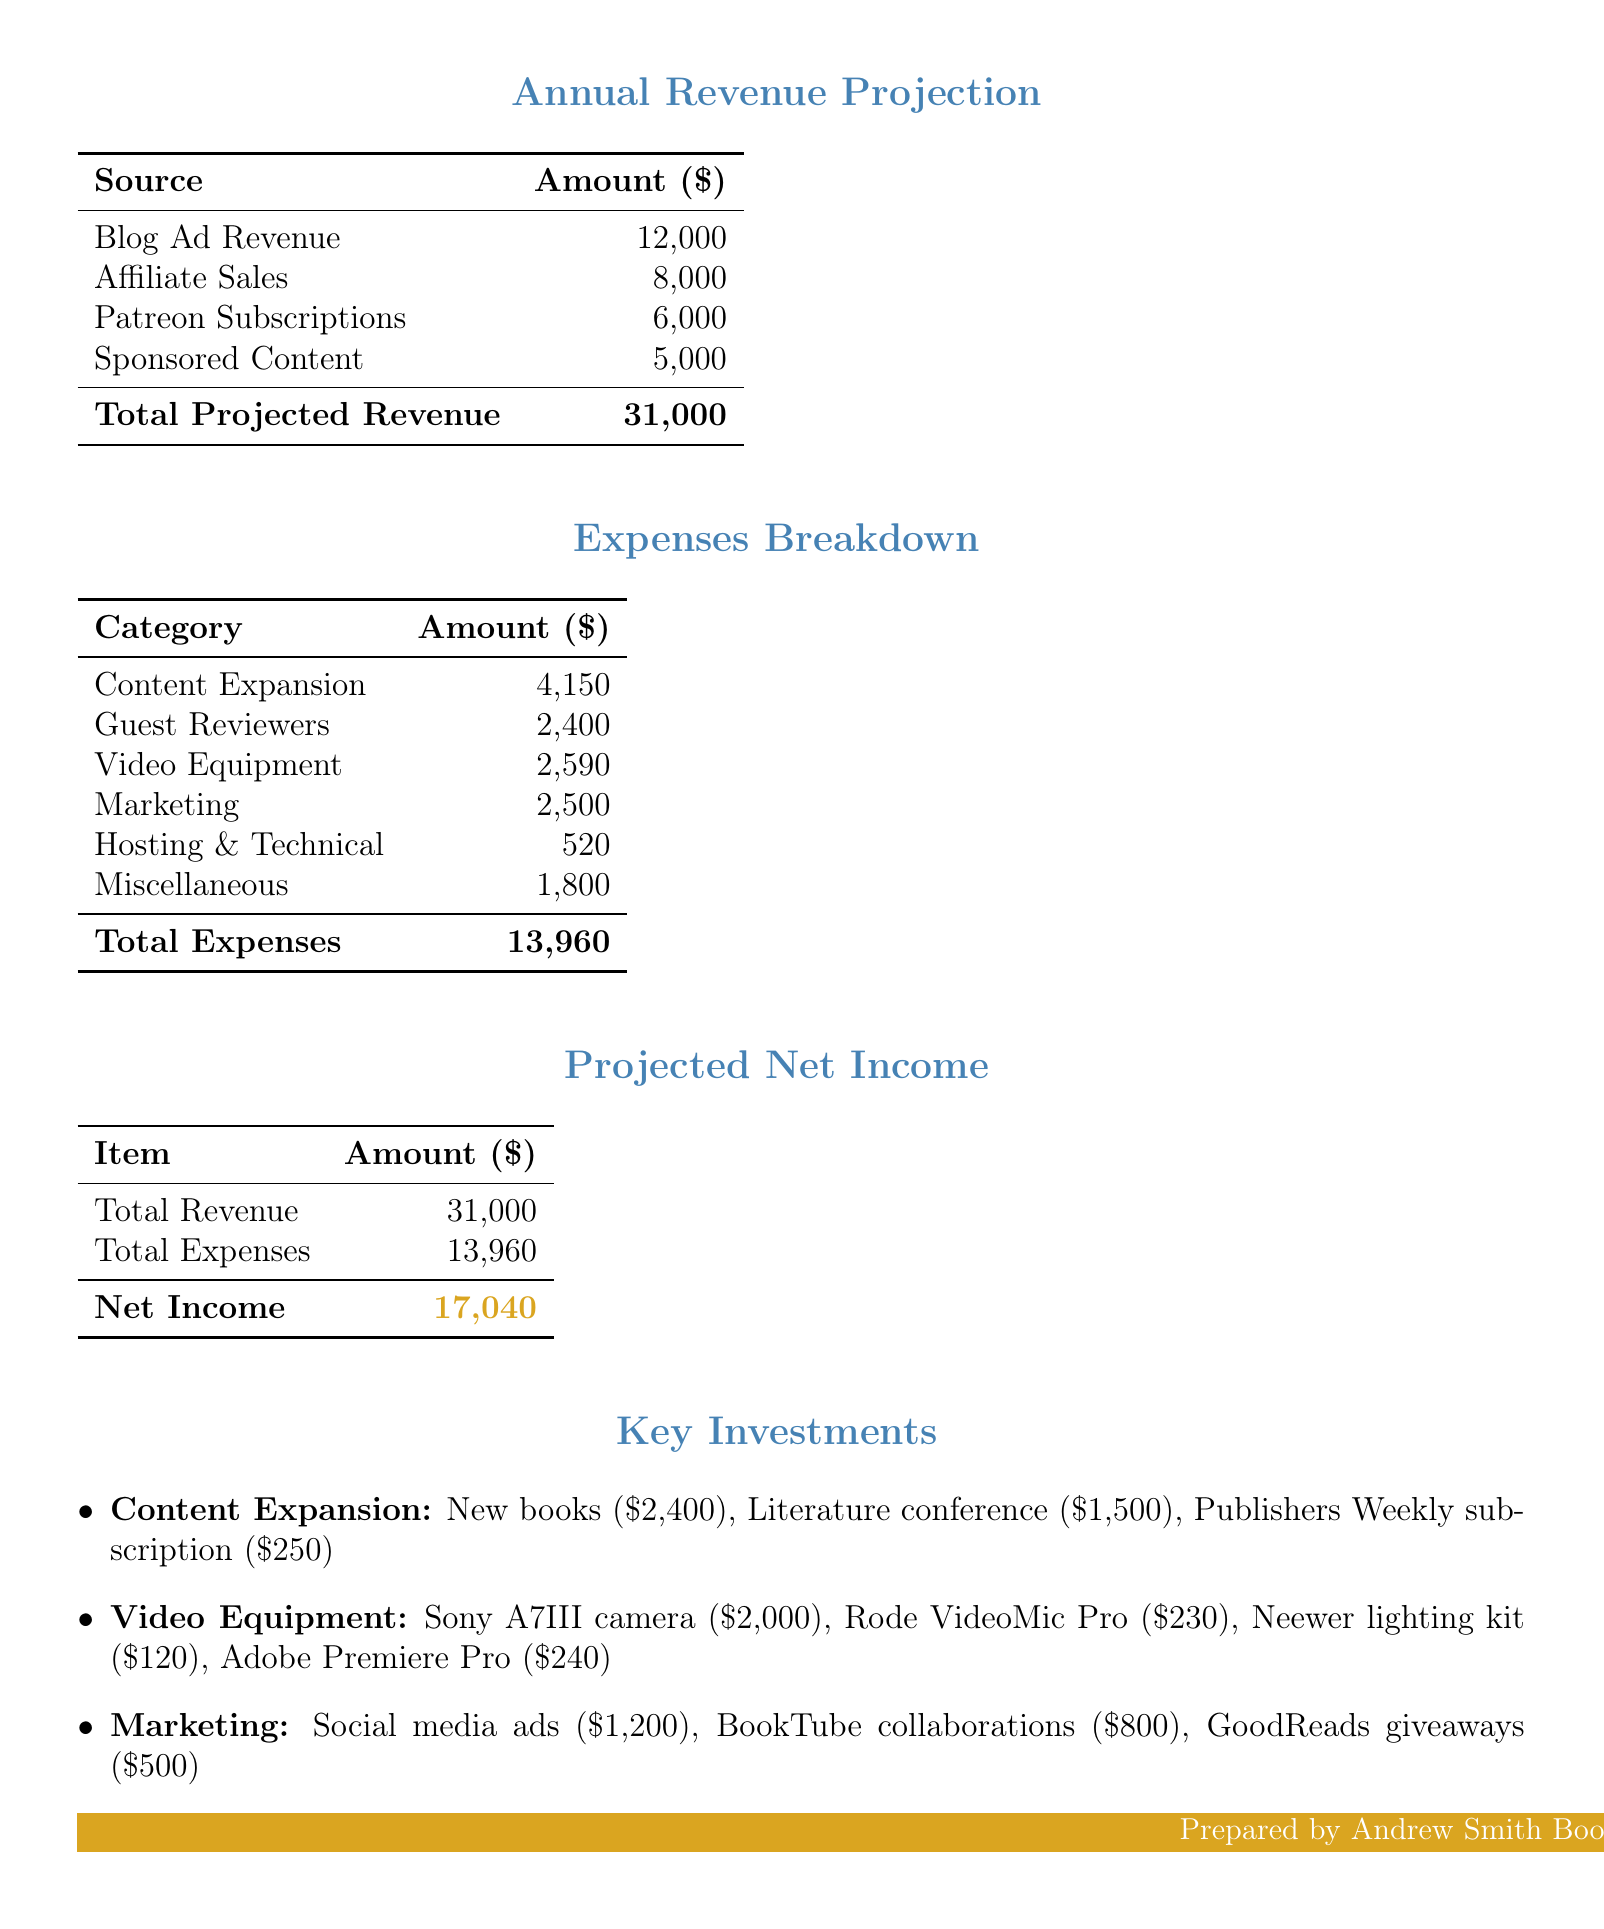What is the total projected revenue? The total projected revenue is calculated by summing all revenue sources listed in the document: $12,000 + $8,000 + $6,000 + $5,000 = $31,000.
Answer: $31,000 How much is allocated for marketing expenses? The marketing expenses include social media ads, BookTube collaborations, and GoodReads giveaways, totaling $1,200 + $800 + $500 = $2,500.
Answer: $2,500 What is the cost of the Sony A7III camera? The document specifies that the cost of the Sony A7III camera is $2,000.
Answer: $2,000 How many guest reviews are planned? The document states that there are 24 planned guest reviews.
Answer: 24 What is the total amount budgeted for guest reviewers? The total guest reviewer cost is indicated as $2,400 for the planned reviews.
Answer: $2,400 What is the total amount for content expansion costs? The content expansion costs are summed as $2,400 + $1,500 + $250 = $4,150.
Answer: $4,150 What is the net income projected? The net income is calculated by subtracting total expenses from total revenue: $31,000 - $13,960 = $17,040.
Answer: $17,040 Which expenses fall under miscellaneous expenses? The miscellaneous expenses listed include office supplies, professional development courses, and a contingency fund.
Answer: Office supplies, professional development courses, contingency fund What is the total investment in video equipment? The total investment in video equipment is calculated as $2,000 + $230 + $120 + $240 = $2,590.
Answer: $2,590 